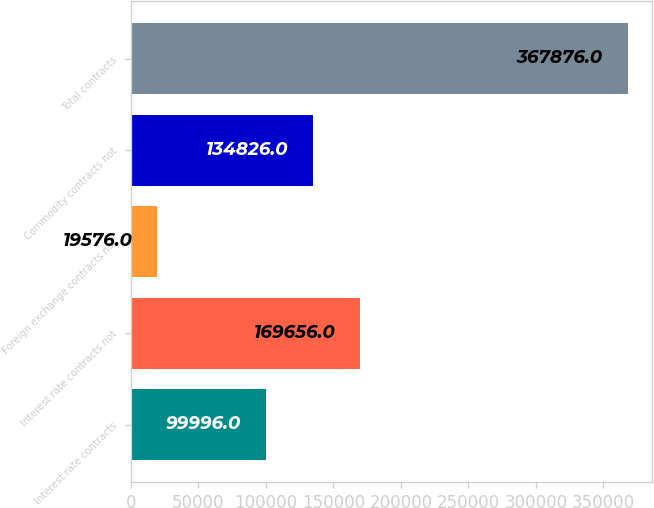Convert chart to OTSL. <chart><loc_0><loc_0><loc_500><loc_500><bar_chart><fcel>Interest rate contracts<fcel>Interest rate contracts not<fcel>Foreign exchange contracts not<fcel>Commodity contracts not<fcel>Total contracts<nl><fcel>99996<fcel>169656<fcel>19576<fcel>134826<fcel>367876<nl></chart> 